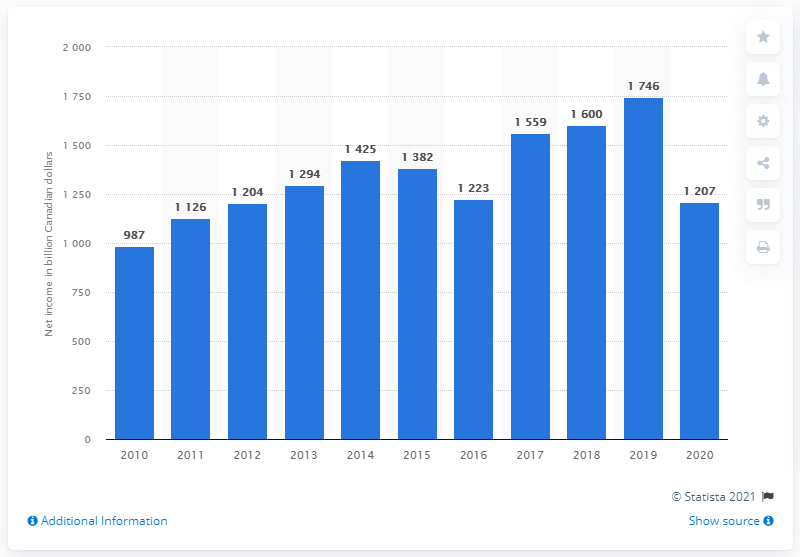Mention a couple of crucial points in this snapshot. In 2012, Telus reported its lowest net income. 